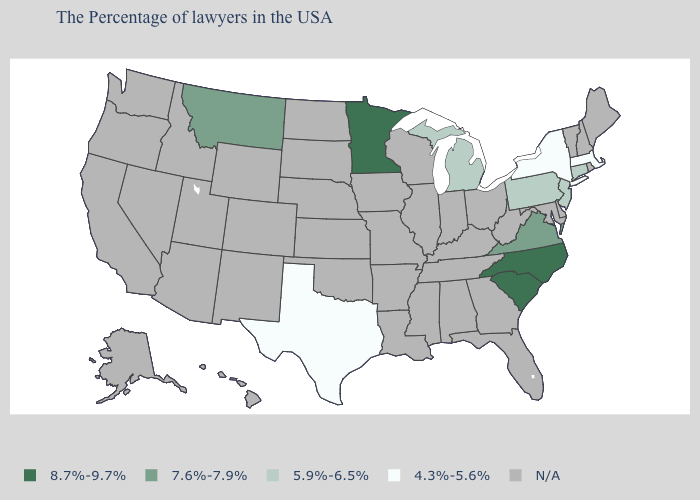Does the first symbol in the legend represent the smallest category?
Quick response, please. No. What is the lowest value in the Northeast?
Quick response, please. 4.3%-5.6%. What is the value of Ohio?
Concise answer only. N/A. What is the value of New Jersey?
Be succinct. 5.9%-6.5%. Among the states that border North Dakota , which have the highest value?
Give a very brief answer. Minnesota. What is the lowest value in the South?
Give a very brief answer. 4.3%-5.6%. What is the value of Alabama?
Keep it brief. N/A. What is the value of Montana?
Keep it brief. 7.6%-7.9%. Name the states that have a value in the range 8.7%-9.7%?
Quick response, please. North Carolina, South Carolina, Minnesota. Name the states that have a value in the range N/A?
Give a very brief answer. Maine, Rhode Island, New Hampshire, Vermont, Delaware, Maryland, West Virginia, Ohio, Florida, Georgia, Kentucky, Indiana, Alabama, Tennessee, Wisconsin, Illinois, Mississippi, Louisiana, Missouri, Arkansas, Iowa, Kansas, Nebraska, Oklahoma, South Dakota, North Dakota, Wyoming, Colorado, New Mexico, Utah, Arizona, Idaho, Nevada, California, Washington, Oregon, Alaska, Hawaii. What is the lowest value in the USA?
Write a very short answer. 4.3%-5.6%. Does New York have the highest value in the USA?
Concise answer only. No. What is the lowest value in the USA?
Short answer required. 4.3%-5.6%. Name the states that have a value in the range 4.3%-5.6%?
Answer briefly. Massachusetts, New York, Texas. Name the states that have a value in the range 5.9%-6.5%?
Quick response, please. Connecticut, New Jersey, Pennsylvania, Michigan. 